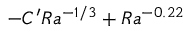<formula> <loc_0><loc_0><loc_500><loc_500>- C ^ { \prime } R a ^ { - 1 / 3 } + R a ^ { - 0 . 2 2 }</formula> 